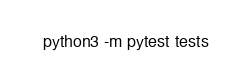<code> <loc_0><loc_0><loc_500><loc_500><_Bash_>python3 -m pytest tests</code> 